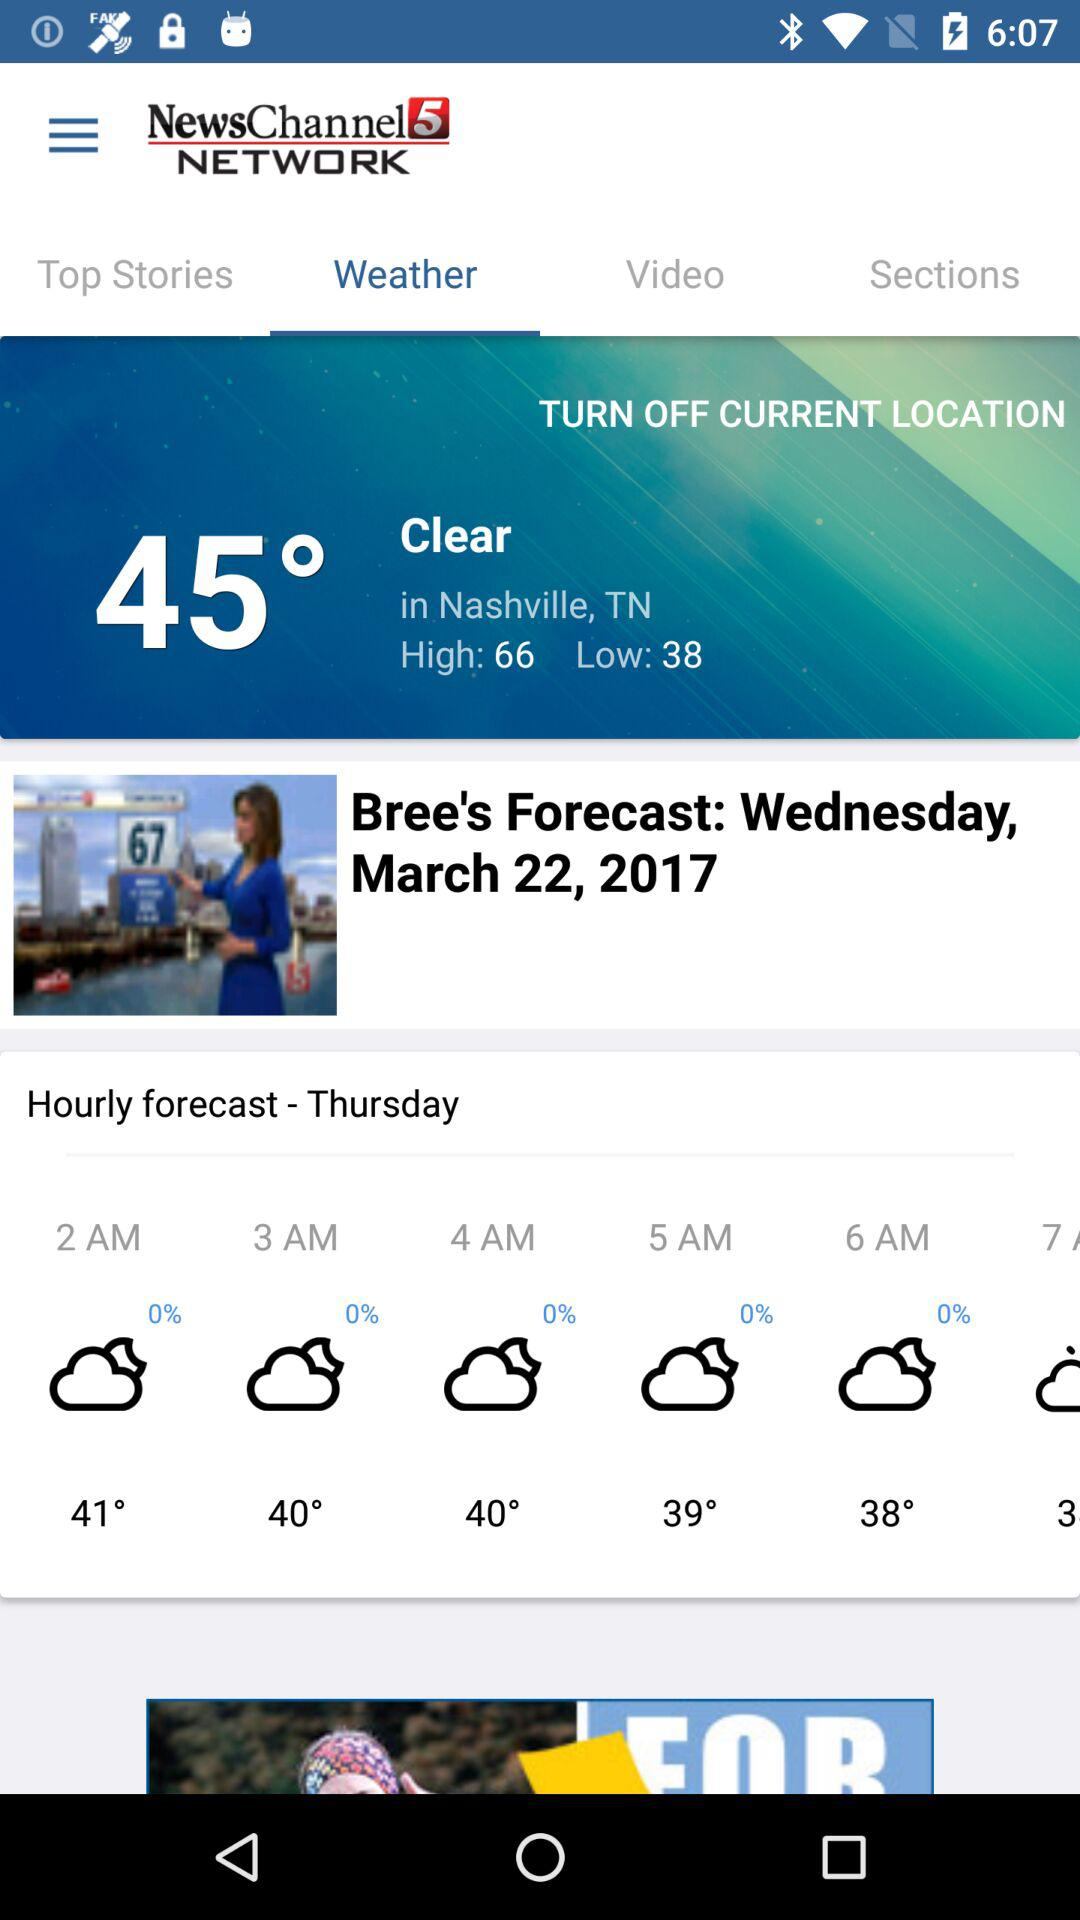Which option is selected? The selected option is "Weather". 